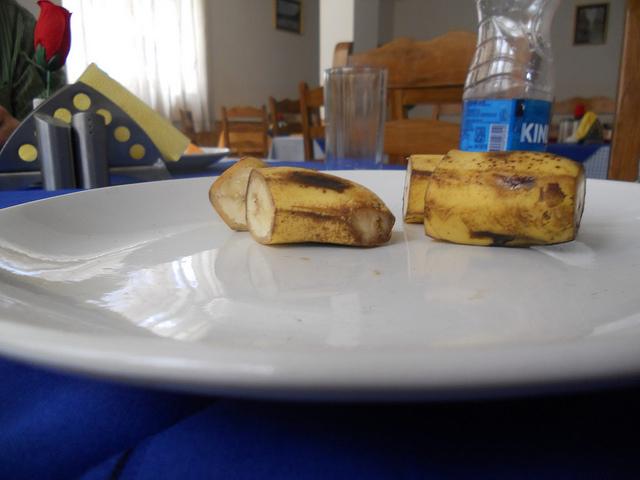Is there a fork sitting on crumbs of food?
Keep it brief. No. What food is this?
Keep it brief. Banana. What fruit is in the middle?
Give a very brief answer. Banana. What color is the tablecloth?
Concise answer only. Blue. How many plates are in the picture?
Write a very short answer. 1. Is this meal healthy?
Answer briefly. Yes. Is it homemade food?
Give a very brief answer. No. How many jellies are there on the table?
Be succinct. 0. What is the fruit on the table?
Answer briefly. Banana. How many pieces of bananas do you count?
Write a very short answer. 4. What are the containers used for?
Concise answer only. Water. Are there crumbs on the plate?
Write a very short answer. No. How many plates are there?
Be succinct. 1. What fruit is in the photo?
Be succinct. Banana. Was this picture taken at a restaurant?
Give a very brief answer. No. How many slices are standing up on their edges?
Quick response, please. 0. What is in the background?
Concise answer only. Chairs. Is the plate half empty?
Quick response, please. Yes. Is this food vegetarian?
Answer briefly. Yes. What food is on the plate?
Give a very brief answer. Banana. Is this a ripe banana?
Concise answer only. Yes. Does this look good to eat?
Answer briefly. No. Is there a soda on the table?
Be succinct. No. 